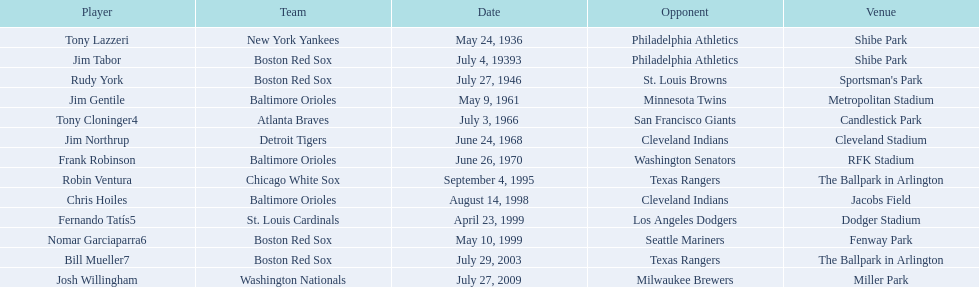What were the specific dates of each match? May 24, 1936, July 4, 19393, July 27, 1946, May 9, 1961, July 3, 1966, June 24, 1968, June 26, 1970, September 4, 1995, August 14, 1998, April 23, 1999, May 10, 1999, July 29, 2003, July 27, 2009. Which teams participated? New York Yankees, Boston Red Sox, Boston Red Sox, Baltimore Orioles, Atlanta Braves, Detroit Tigers, Baltimore Orioles, Chicago White Sox, Baltimore Orioles, St. Louis Cardinals, Boston Red Sox, Boston Red Sox, Washington Nationals. Who were their adversaries? Philadelphia Athletics, Philadelphia Athletics, St. Louis Browns, Minnesota Twins, San Francisco Giants, Cleveland Indians, Washington Senators, Texas Rangers, Cleveland Indians, Los Angeles Dodgers, Seattle Mariners, Texas Rangers, Milwaukee Brewers. And when did the detroit tigers compete with the cleveland indians? June 24, 1968. Who are the competitors of the boston red sox throughout baseball home run records? Philadelphia Athletics, St. Louis Browns, Seattle Mariners, Texas Rangers. Can you give me this table in json format? {'header': ['Player', 'Team', 'Date', 'Opponent', 'Venue'], 'rows': [['Tony Lazzeri', 'New York Yankees', 'May 24, 1936', 'Philadelphia Athletics', 'Shibe Park'], ['Jim Tabor', 'Boston Red Sox', 'July 4, 19393', 'Philadelphia Athletics', 'Shibe Park'], ['Rudy York', 'Boston Red Sox', 'July 27, 1946', 'St. Louis Browns', "Sportsman's Park"], ['Jim Gentile', 'Baltimore Orioles', 'May 9, 1961', 'Minnesota Twins', 'Metropolitan Stadium'], ['Tony Cloninger4', 'Atlanta Braves', 'July 3, 1966', 'San Francisco Giants', 'Candlestick Park'], ['Jim Northrup', 'Detroit Tigers', 'June 24, 1968', 'Cleveland Indians', 'Cleveland Stadium'], ['Frank Robinson', 'Baltimore Orioles', 'June 26, 1970', 'Washington Senators', 'RFK Stadium'], ['Robin Ventura', 'Chicago White Sox', 'September 4, 1995', 'Texas Rangers', 'The Ballpark in Arlington'], ['Chris Hoiles', 'Baltimore Orioles', 'August 14, 1998', 'Cleveland Indians', 'Jacobs Field'], ['Fernando Tatís5', 'St. Louis Cardinals', 'April 23, 1999', 'Los Angeles Dodgers', 'Dodger Stadium'], ['Nomar Garciaparra6', 'Boston Red Sox', 'May 10, 1999', 'Seattle Mariners', 'Fenway Park'], ['Bill Mueller7', 'Boston Red Sox', 'July 29, 2003', 'Texas Rangers', 'The Ballpark in Arlington'], ['Josh Willingham', 'Washington Nationals', 'July 27, 2009', 'Milwaukee Brewers', 'Miller Park']]} Of these, which one was the competitor on july 27, 1946? St. Louis Browns. 